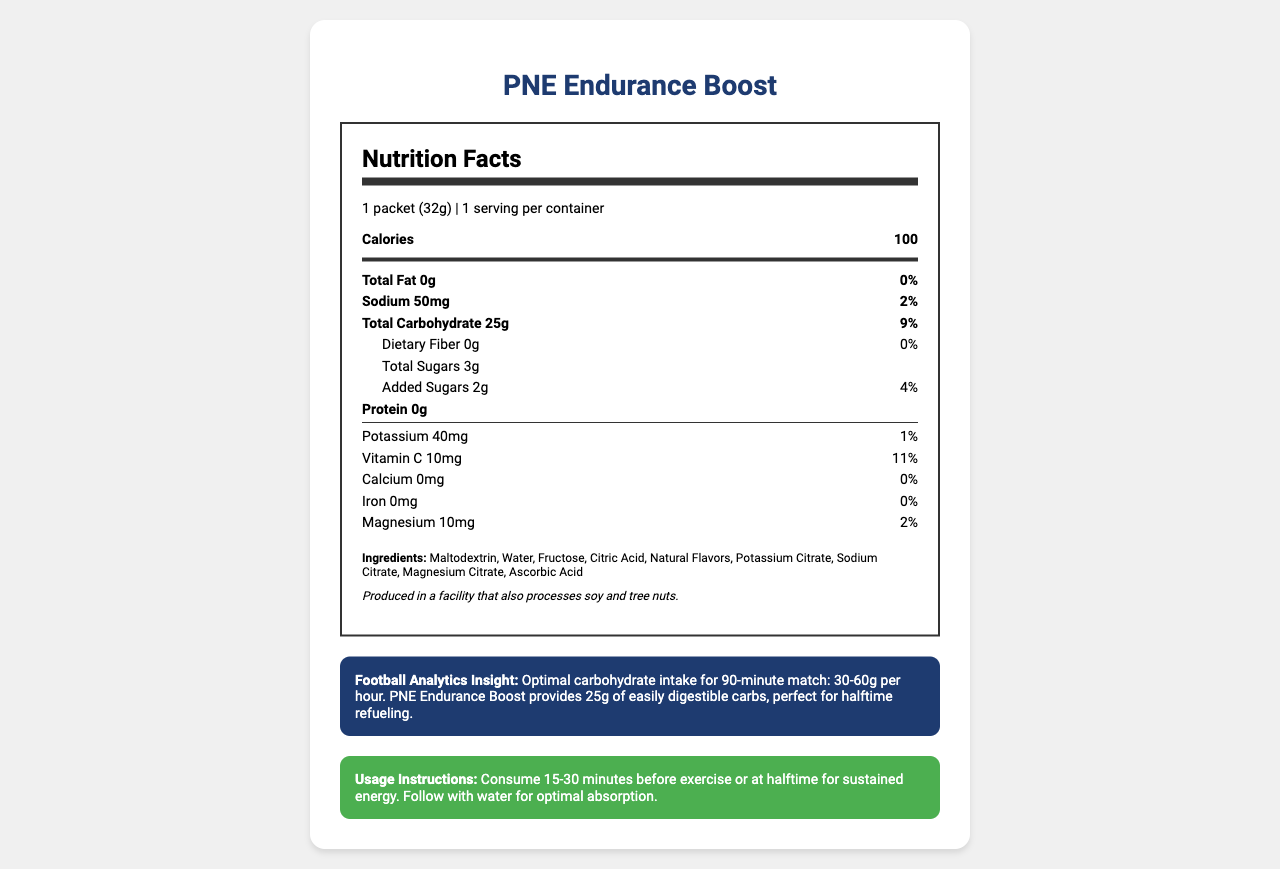What is the serving size of the PNE Endurance Boost? The document lists the serving size as "1 packet (32g)."
Answer: 1 packet (32g) How many grams of carbohydrates are in one serving of PNE Endurance Boost? The Total Carbohydrate section mentions 25g of carbohydrates per serving.
Answer: 25g What percentage of the daily value of added sugars does the energy gel provide? The document states that there are 2g of added sugars which represent 4% of the daily value.
Answer: 4% How much sodium does one serving contain? The nutrition facts indicate that the sodium content is 50mg per serving.
Answer: 50mg What is the total number of calories per serving of the PNE Endurance Boost? The total number of calories per serving is stated as 100.
Answer: 100 calories What are the main ingredients listed on the label? The ingredients section lists all these components.
Answer: Maltodextrin, Water, Fructose, Citric Acid, Natural Flavors, Potassium Citrate, Sodium Citrate, Magnesium Citrate, Ascorbic Acid How should this energy gel be consumed according to the usage instructions? The usage instructions state to consume it 15-30 minutes before exercise or at halftime, and to follow it with water for optimal absorption.
Answer: Consume 15-30 minutes before exercise or at halftime for sustained energy. Follow with water for optimal absorption. Who collaborated on developing the PNE Endurance Boost? The document mentions the gel was developed in collaboration with Preston North End's sports nutrition team.
Answer: Preston North End's sports nutrition team Which mineral is present in the smallest amount in the PNE Endurance Boost? The document shows 0mg for calcium, making it the smallest amount among listed minerals.
Answer: Calcium True or False: The PNE Endurance Boost contains protein. The nutrition label states that the protein content is 0g.
Answer: False Which of the following nutrients is not listed on the Nutrition Facts label? A. Vitamin D B. Vitamin C C. Magnesium D. Potassium The document lists Vitamin C, Magnesium, and Potassium but does not mention Vitamin D.
Answer: A. Vitamin D What are the benefits of consuming the PNE Endurance Boost during a 90-minute football match? A. Provides fast recovery B. Offers sustained energy C. Supplies necessary protein The football analytics insight mentions the gel provides 25g of easily digestible carbs, perfect for halftime refueling and sustained energy.
Answer: B. Offers sustained energy What is the total amount of sugars in the PNE Endurance Boost, including both natural and added sugars? The total sugar section specifies that there are 3g of total sugars.
Answer: 3g Summarize the usage and nutritional features of the PNE Endurance Boost. This summary includes key points about the energy gel’s nutritional content, usage instructions, and development background.
Answer: The PNE Endurance Boost is an energy gel designed for endurance athletes, especially football players, containing 25g of easily digestible carbohydrates and providing 100 calories per serving. It contains 3g of total sugars (with 2g being added sugars), 50mg of sodium, and minor amounts of potassium, vitamin C, and magnesium. It is recommended for consumption 15-30 minutes before exercise or at halftime, followed by water for optimal absorption. Developed with Preston North End's nutrition team, it is gluten-free but processed in a facility that handles soy and tree nuts. What are the daily values of dietary fiber and iron in the PNE Endurance Boost? The document shows 0g of dietary fiber with no daily value percentage and 0mg of iron with a daily value of 0%.
Answer: Not available for dietary fiber and 0% for iron What is the main purpose of the PNE Endurance Boost's carbohydrate content in the context of football analytics? The football analytics insight states that the PNE Endurance Boost provides 25g of easily digestible carbohydrates, making it perfect for halftime refueling during intense training and matches.
Answer: Optimal halftime refueling How does the PNE Endurance Boost relate to Preston North End? The document mentions it was specifically developed with input from Preston North End's sports nutrition team to meet the needs of football players.
Answer: It was developed in collaboration with Preston North End's sports nutrition team. Which of the following minerals is not included in the PNE Endurance Boost? A. Iron B. Potassium C. Zinc D. Magnesium The document lists Iron, Potassium, and Magnesium but does not include Zinc.
Answer: C. Zinc What type of facility is the PNE Endurance Boost produced in? The allergen information states that it is produced in a facility that also processes soy and tree nuts.
Answer: A facility that processes soy and tree nuts. Does the energy gel provide any dietary fiber? The document states that the dietary fiber content is 0g, indicating no dietary fiber is present.
Answer: No 